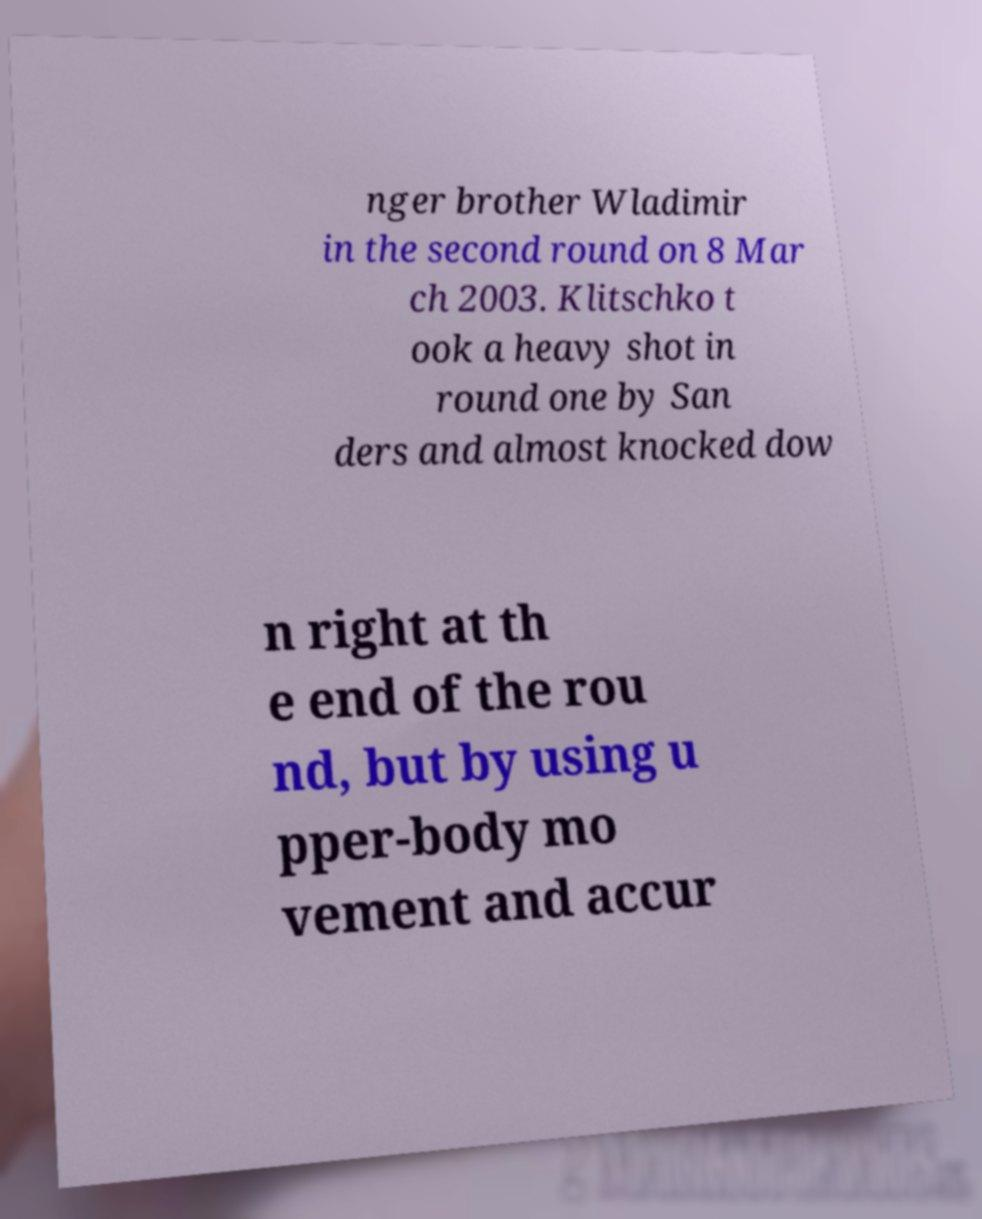Can you accurately transcribe the text from the provided image for me? nger brother Wladimir in the second round on 8 Mar ch 2003. Klitschko t ook a heavy shot in round one by San ders and almost knocked dow n right at th e end of the rou nd, but by using u pper-body mo vement and accur 